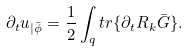<formula> <loc_0><loc_0><loc_500><loc_500>\partial _ { t } u _ { | \bar { \phi } } = \frac { 1 } { 2 } \int _ { q } t r \{ \partial _ { t } R _ { k } \bar { G } \} .</formula> 